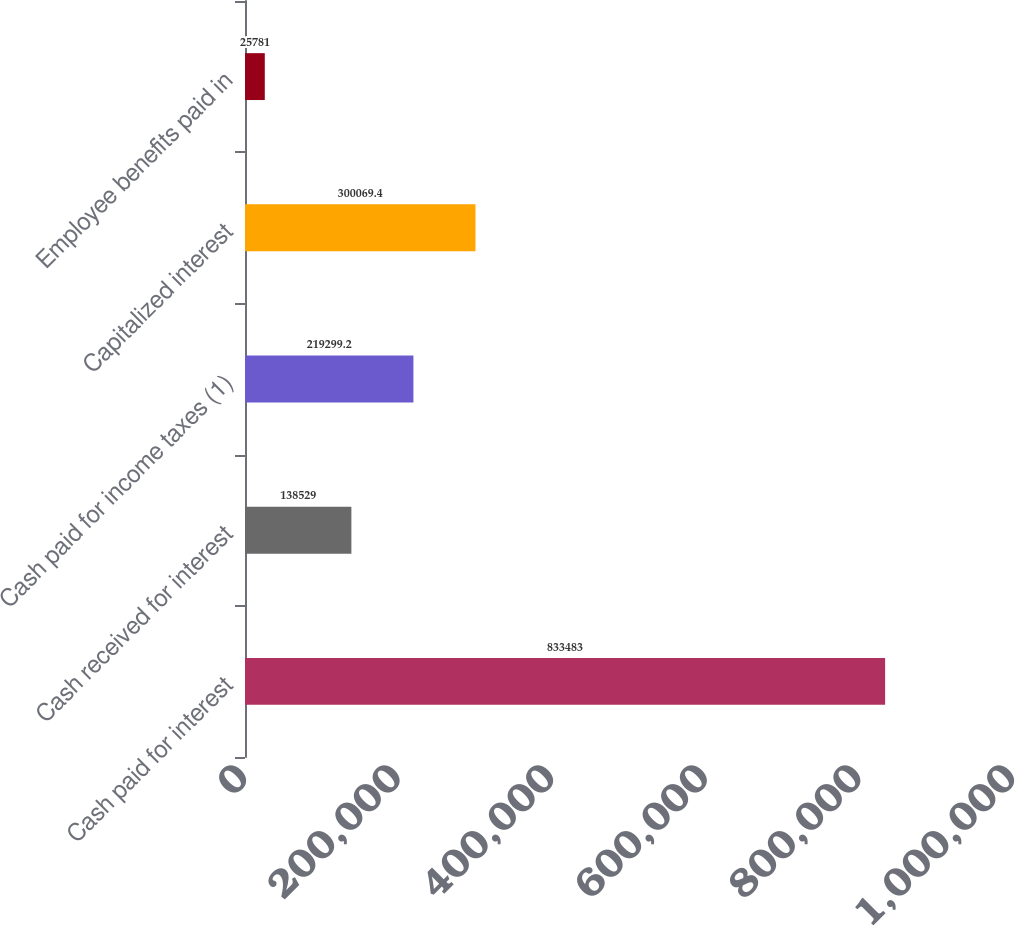Convert chart to OTSL. <chart><loc_0><loc_0><loc_500><loc_500><bar_chart><fcel>Cash paid for interest<fcel>Cash received for interest<fcel>Cash paid for income taxes (1)<fcel>Capitalized interest<fcel>Employee benefits paid in<nl><fcel>833483<fcel>138529<fcel>219299<fcel>300069<fcel>25781<nl></chart> 